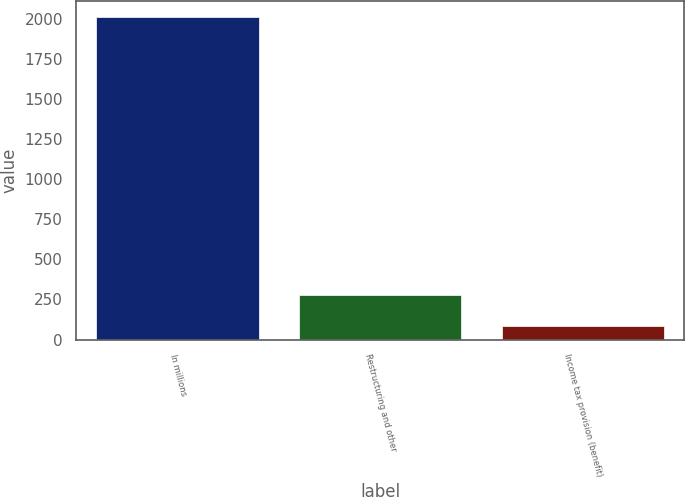Convert chart. <chart><loc_0><loc_0><loc_500><loc_500><bar_chart><fcel>In millions<fcel>Restructuring and other<fcel>Income tax provision (benefit)<nl><fcel>2012<fcel>277.7<fcel>85<nl></chart> 